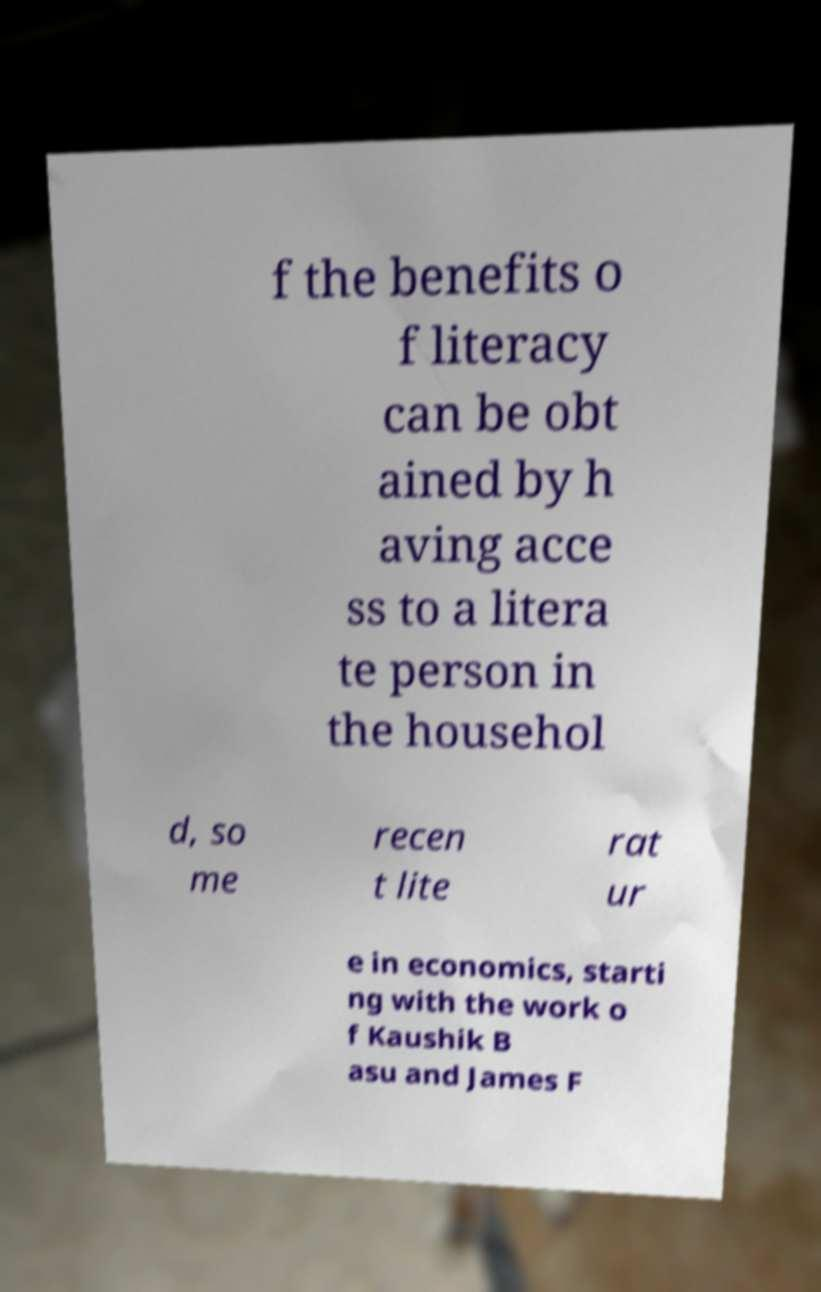Can you read and provide the text displayed in the image?This photo seems to have some interesting text. Can you extract and type it out for me? f the benefits o f literacy can be obt ained by h aving acce ss to a litera te person in the househol d, so me recen t lite rat ur e in economics, starti ng with the work o f Kaushik B asu and James F 